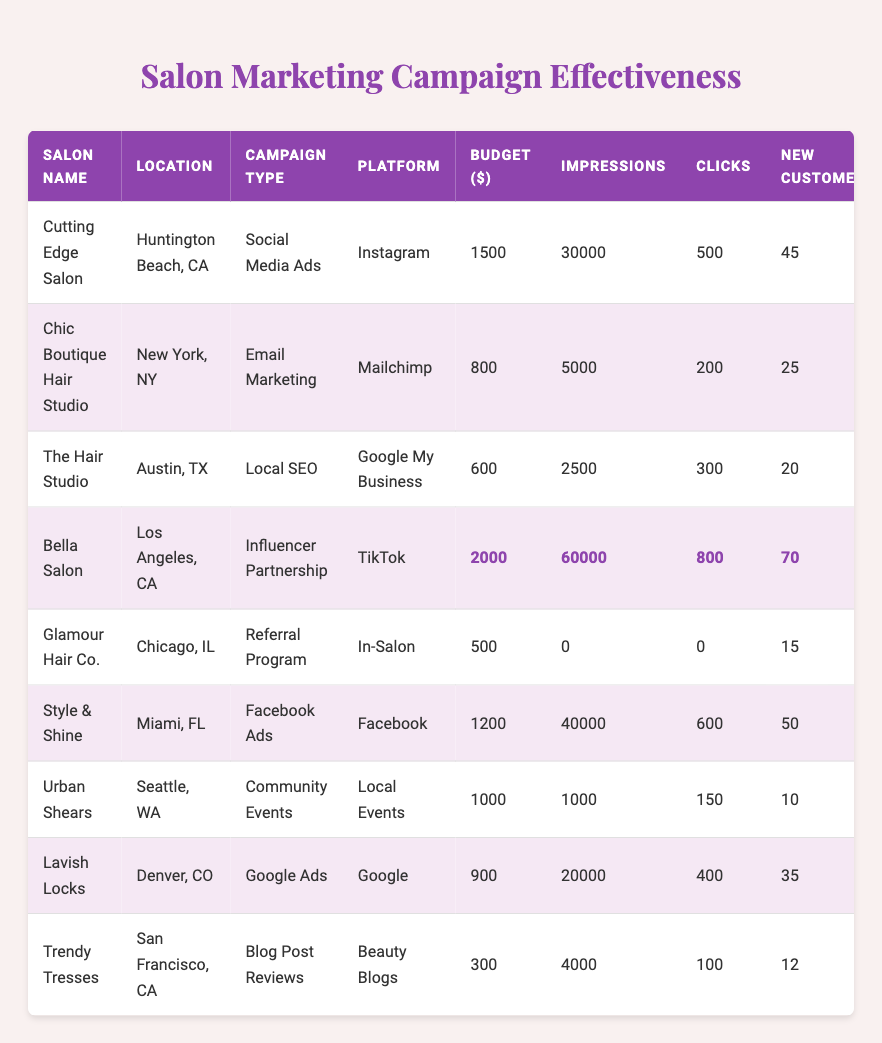What is the highest customer feedback score among the salons? The table shows customer feedback scores for each salon. Scanning through the "Feedback Score" column, The Hair Studio has the highest score of 4.9.
Answer: 4.9 Which salon had the lowest budget for their marketing campaign? The budget values are listed in the "Budget ($)" column. Urban Shears has the lowest budget of $1000.
Answer: 500 How many new customers did Bella Salon acquire? Bella Salon's "New Customers" column shows that they gained 70 new customers.
Answer: 70 What is the total budget spent on marketing campaigns by all salons? The budgets from each salon are summed: 1500 + 800 + 600 + 2000 + 500 + 1200 + 1000 + 900 + 300 = 7500.
Answer: 7500 Which marketing campaign type brought in the most new customers? Comparing the "New Customers" column by campaign type: Influencer Partnership at Bella Salon brought in the most at 70 new customers.
Answer: Influencer Partnership What was the average customer feedback score across all salons? The scores are: 4.7, 4.5, 4.9, 4.8, 4.6, 4.5, 4.8, 4.4, 4.3. Adding these gives 40.5. Dividing by 9 (the number of salons) gives an average of 4.5.
Answer: 4.5 Which location has the salon with the highest impressions? Checking the "Impressions" column, Bella Salon had the highest impressions at 60,000. The location is Los Angeles, CA.
Answer: Los Angeles, CA Did Glamour Hair Co. generate any impressions from their referral program? The "Impressions" column shows 0 for Glamour Hair Co.'s referral program. Therefore, they did not generate any impressions.
Answer: No How many clicks did Style & Shine generate from their Facebook Ads? The "Clicks" column indicates Style & Shine generated 600 clicks.
Answer: 600 What is the total number of new customers from all campaigns combined? Adding the new customers for each salon: 45 + 25 + 20 + 70 + 15 + 50 + 10 + 35 + 12 = 282.
Answer: 282 Which salon achieved the most clicks in their marketing campaign? The "Clicks" column indicates Bella Salon achieved the most clicks with 800.
Answer: Bella Salon 